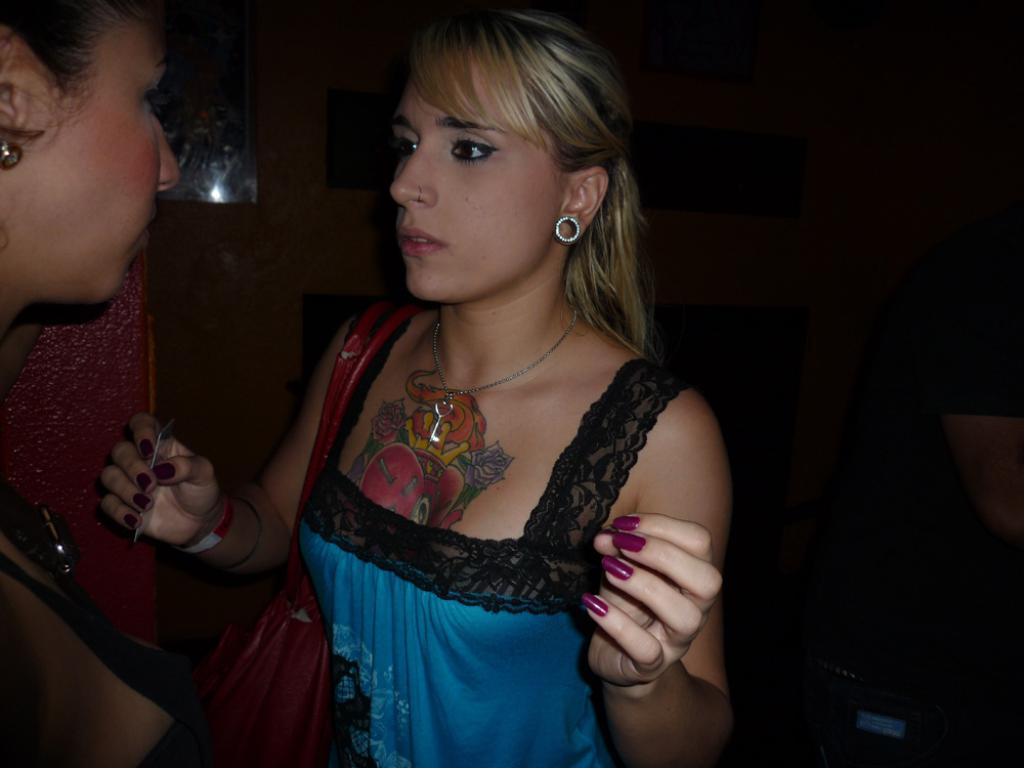How many people are in the image? There are two women in the image. What are the women doing in the image? The women are standing in opposite directions. What type of mouth can be seen on the oven in the image? There is no oven present in the image, and therefore no mouth on an oven can be observed. 